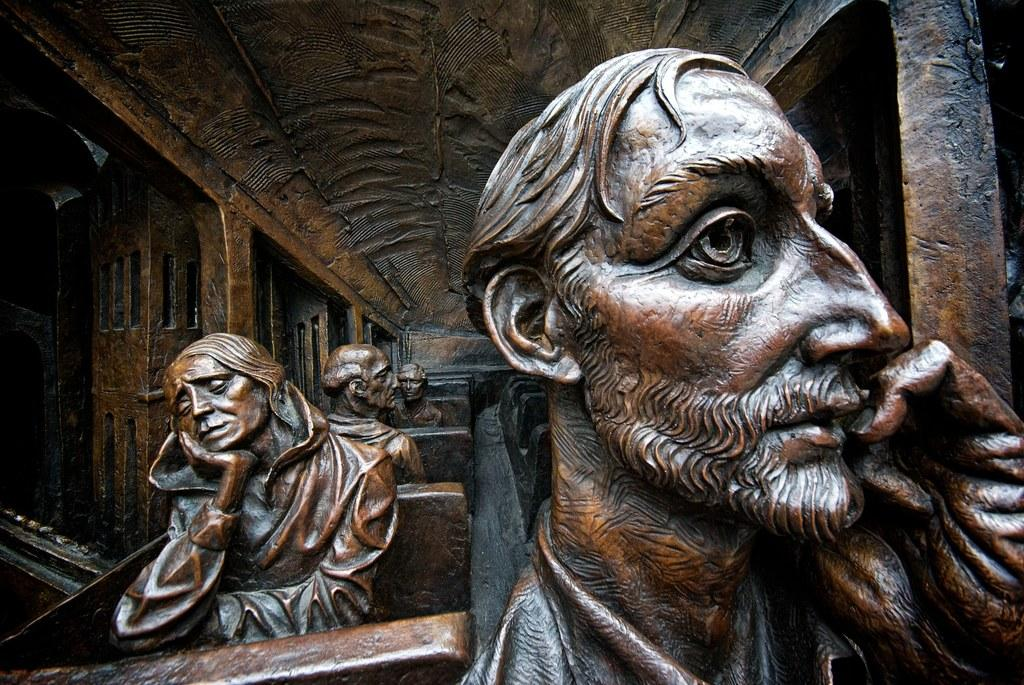What objects are present in the image that resemble people? There are statues in the image. How are the statues positioned? The statues are in a sitting position. What are the statues sitting on? The statues are on chairs. Where are these chairs located? The chairs are part of an architectural building. Can you see any fans in the image? There are no fans visible in the image. Is there a harbor present in the image? There is no harbor present in the image. 